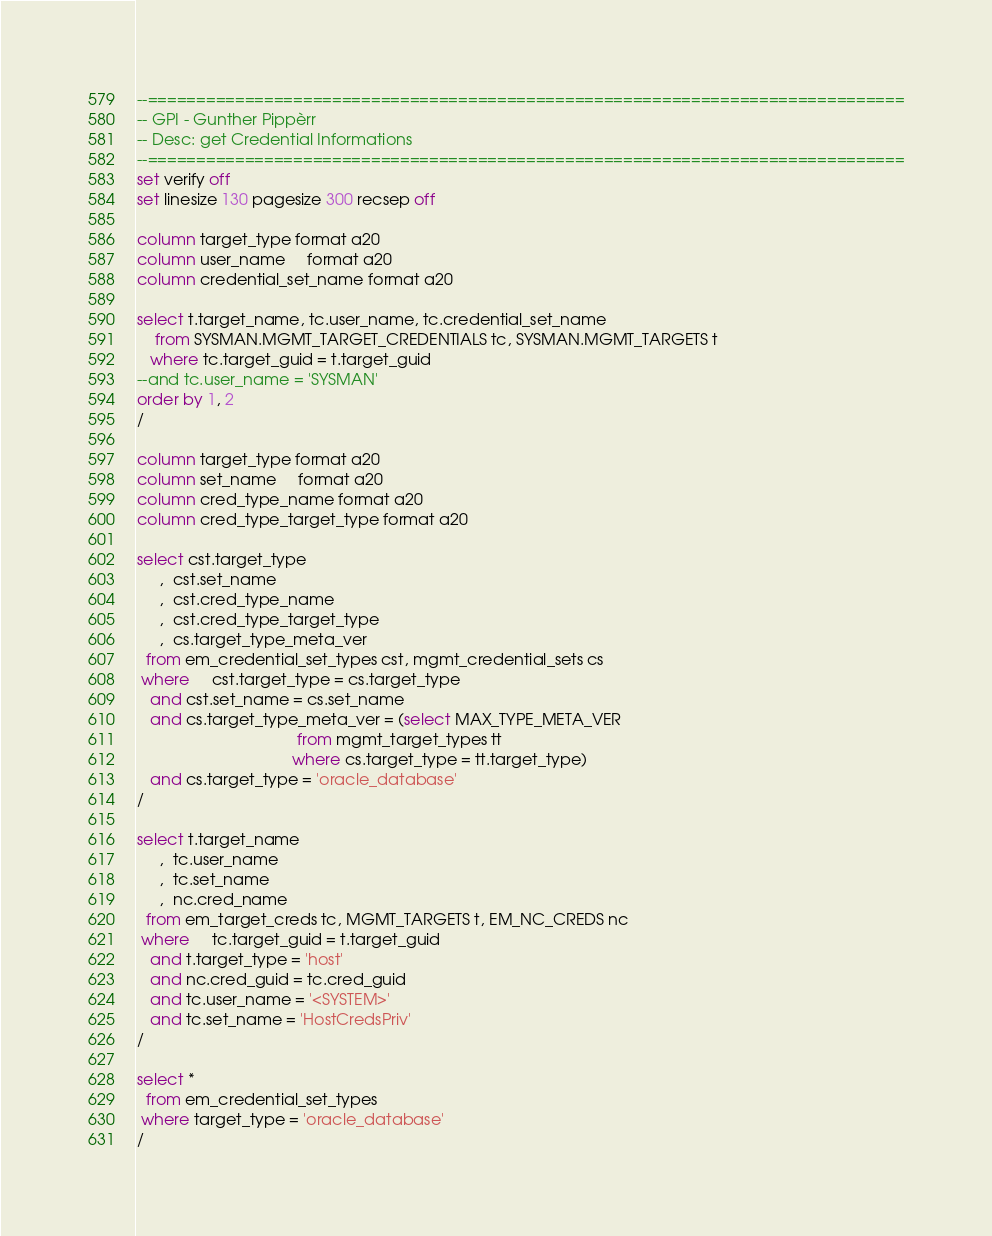Convert code to text. <code><loc_0><loc_0><loc_500><loc_500><_SQL_>--==============================================================================
-- GPI - Gunther Pippèrr
-- Desc: get Credential Informations 
--==============================================================================
set verify off
set linesize 130 pagesize 300 recsep off

column target_type format a20
column user_name     format a20
column credential_set_name format a20

select t.target_name, tc.user_name, tc.credential_set_name
    from SYSMAN.MGMT_TARGET_CREDENTIALS tc, SYSMAN.MGMT_TARGETS t
   where tc.target_guid = t.target_guid
--and tc.user_name = 'SYSMAN'
order by 1, 2
/

column target_type format a20
column set_name     format a20
column cred_type_name format a20
column cred_type_target_type format a20

select cst.target_type
     ,  cst.set_name
     ,  cst.cred_type_name
     ,  cst.cred_type_target_type
     ,  cs.target_type_meta_ver
  from em_credential_set_types cst, mgmt_credential_sets cs
 where     cst.target_type = cs.target_type
   and cst.set_name = cs.set_name
   and cs.target_type_meta_ver = (select MAX_TYPE_META_VER
                                    from mgmt_target_types tt
                                   where cs.target_type = tt.target_type)
   and cs.target_type = 'oracle_database'
/

select t.target_name
     ,  tc.user_name
     ,  tc.set_name
     ,  nc.cred_name
  from em_target_creds tc, MGMT_TARGETS t, EM_NC_CREDS nc
 where     tc.target_guid = t.target_guid
   and t.target_type = 'host'
   and nc.cred_guid = tc.cred_guid
   and tc.user_name = '<SYSTEM>'
   and tc.set_name = 'HostCredsPriv'
/

select *
  from em_credential_set_types
 where target_type = 'oracle_database'
/		
</code> 